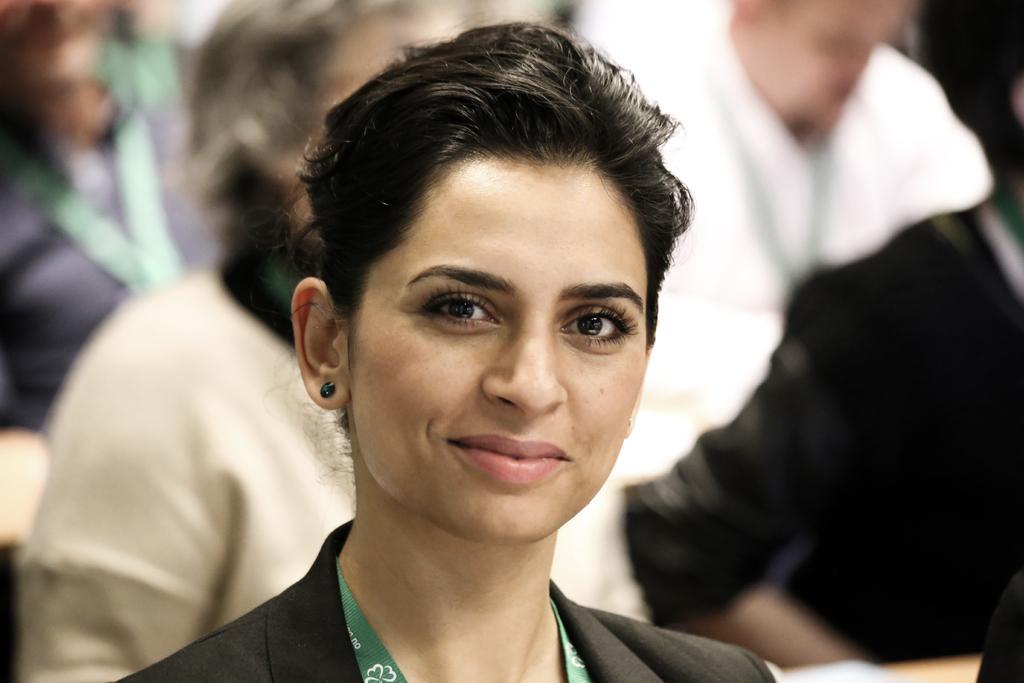Please provide a concise description of this image. There is a woman smiling. In the background, there are other persons in different color dresses. 